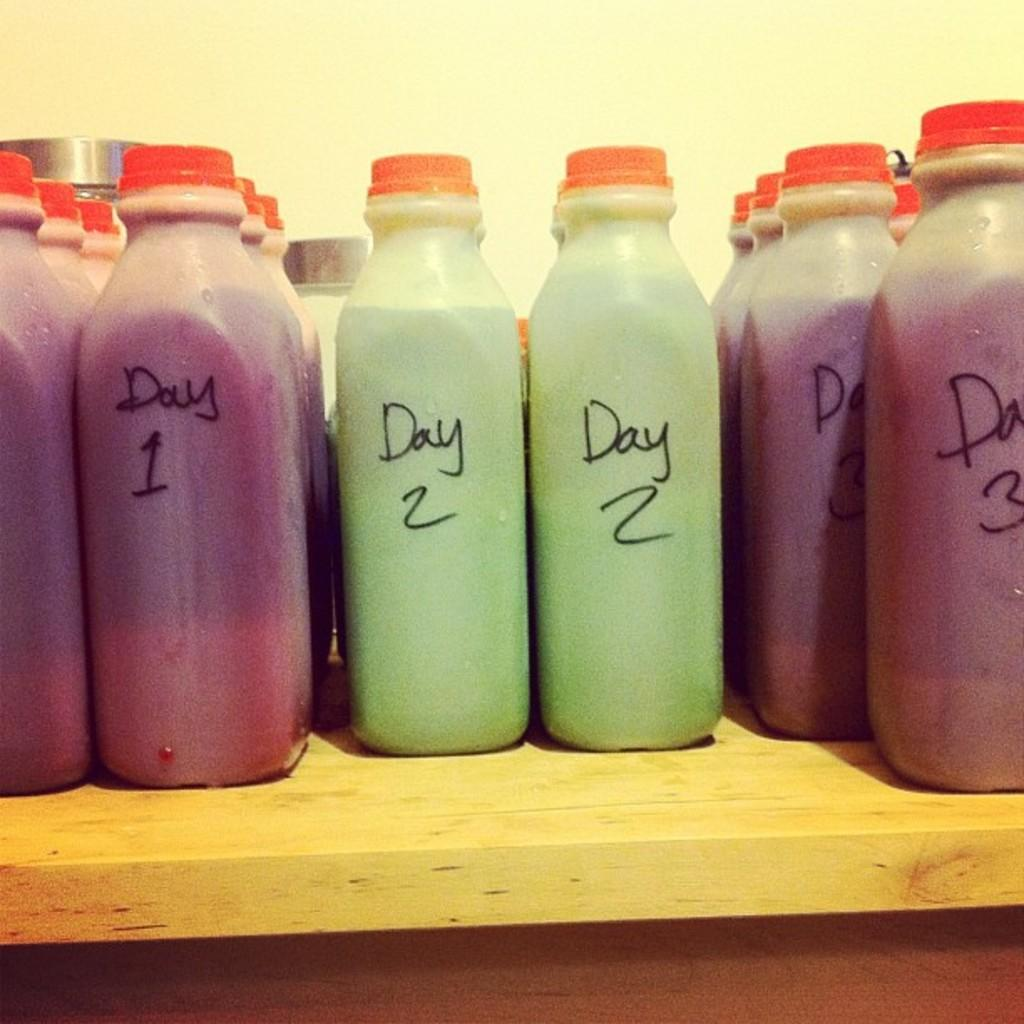<image>
Give a short and clear explanation of the subsequent image. Bottles that are labeled day 1 and day 2 are lined up in rows on a shelf. 